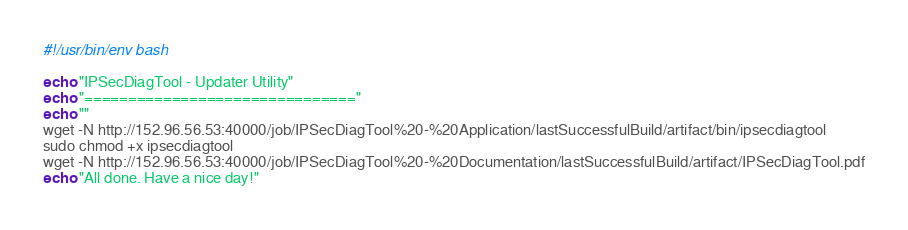<code> <loc_0><loc_0><loc_500><loc_500><_Bash_>#!/usr/bin/env bash

echo "IPSecDiagTool - Updater Utility"
echo "==============================="
echo ""
wget -N http://152.96.56.53:40000/job/IPSecDiagTool%20-%20Application/lastSuccessfulBuild/artifact/bin/ipsecdiagtool
sudo chmod +x ipsecdiagtool
wget -N http://152.96.56.53:40000/job/IPSecDiagTool%20-%20Documentation/lastSuccessfulBuild/artifact/IPSecDiagTool.pdf
echo "All done. Have a nice day!"</code> 